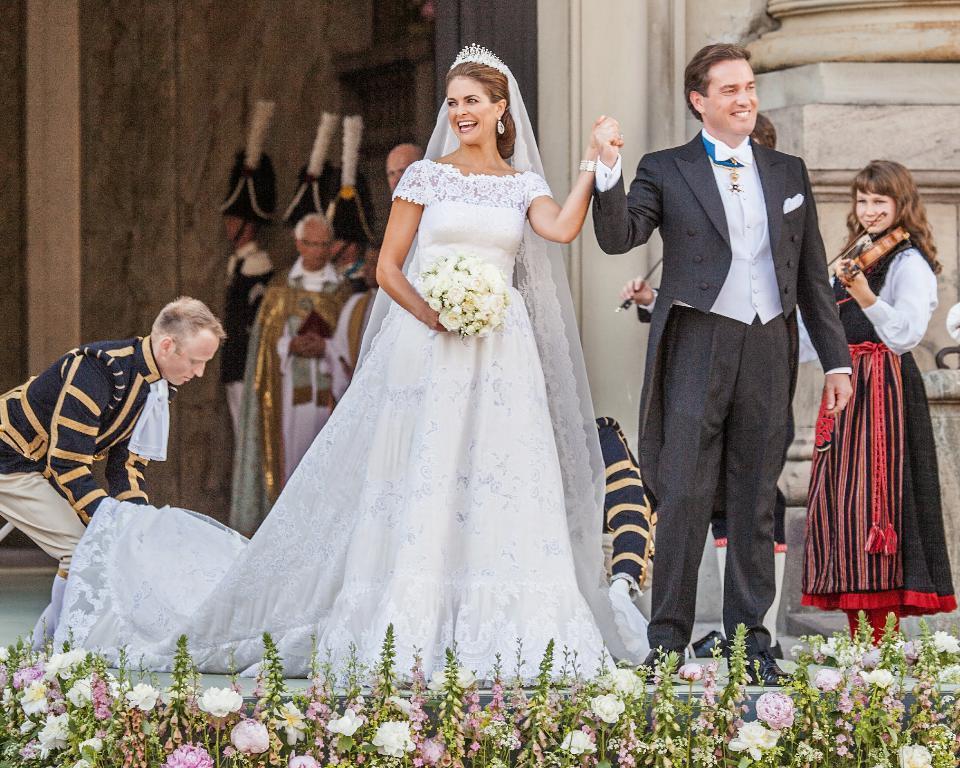Can you describe this image briefly? In the center of the image we can see a bride and groom and they both are smiling and holding there hands each other and a bride is holding a bouquet. In the background of the image we can see the wall and some people are standing and some of them are playing guitar. On the left side of the image we can see a man is holding the bride frock. At the bottom of the image we can see the floor, flowers and plants. 